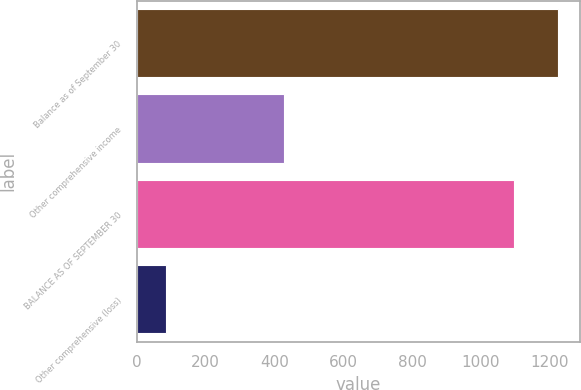<chart> <loc_0><loc_0><loc_500><loc_500><bar_chart><fcel>Balance as of September 30<fcel>Other comprehensive income<fcel>BALANCE AS OF SEPTEMBER 30<fcel>Other comprehensive (loss)<nl><fcel>1226<fcel>428.94<fcel>1097.1<fcel>85.6<nl></chart> 